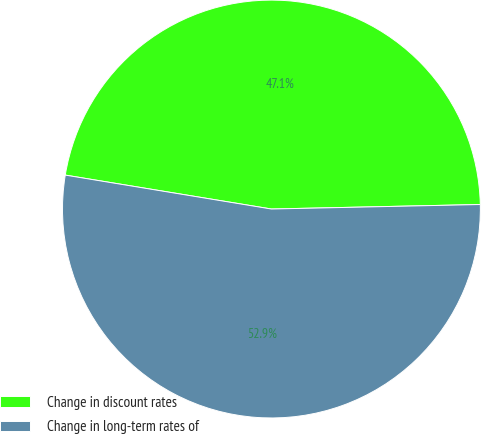<chart> <loc_0><loc_0><loc_500><loc_500><pie_chart><fcel>Change in discount rates<fcel>Change in long-term rates of<nl><fcel>47.06%<fcel>52.94%<nl></chart> 